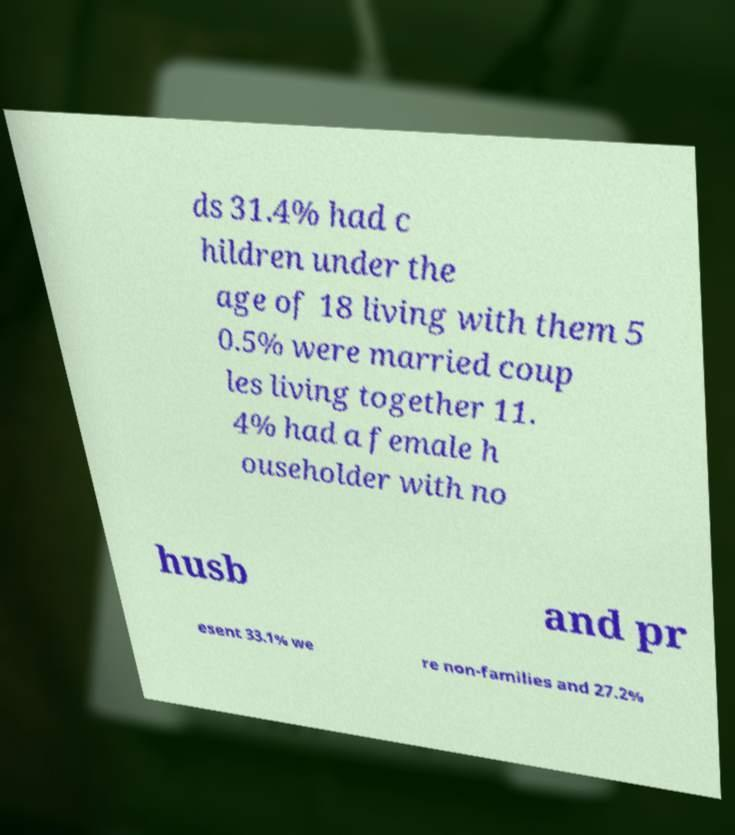There's text embedded in this image that I need extracted. Can you transcribe it verbatim? ds 31.4% had c hildren under the age of 18 living with them 5 0.5% were married coup les living together 11. 4% had a female h ouseholder with no husb and pr esent 33.1% we re non-families and 27.2% 